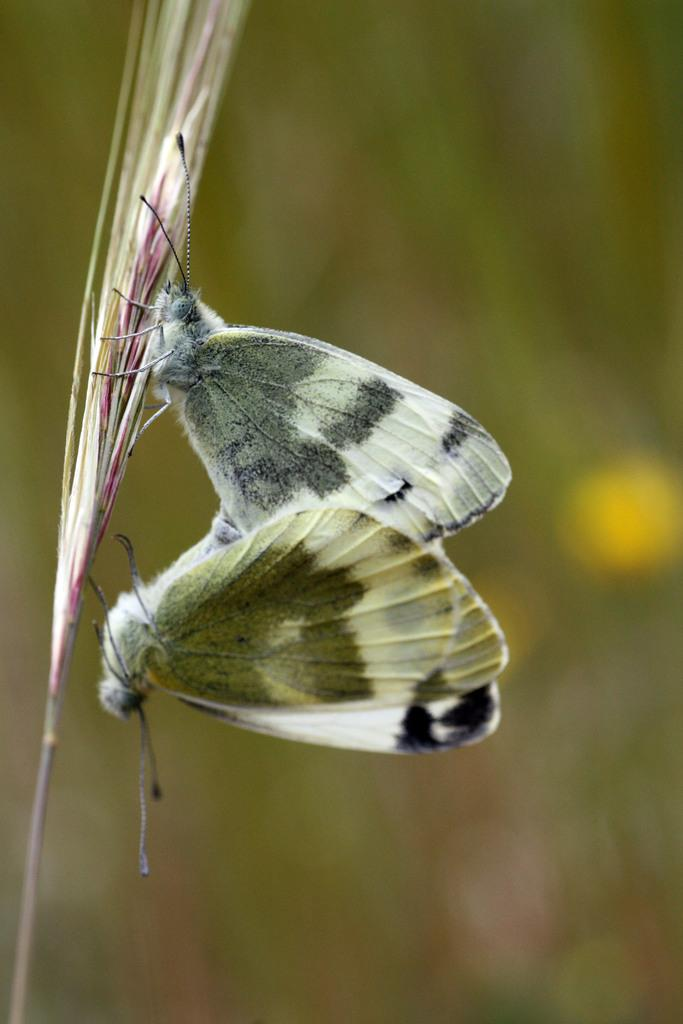How many butterflies are present in the image? There are two butterflies in the image. What are the butterflies standing on? The butterflies are standing on a leaf. Can you describe the background of the image? The background of the image is blurred. What type of quiver is the butterfly using to store its magic in the image? There is no quiver or magic present in the image; it features two butterflies standing on a leaf with a blurred background. 